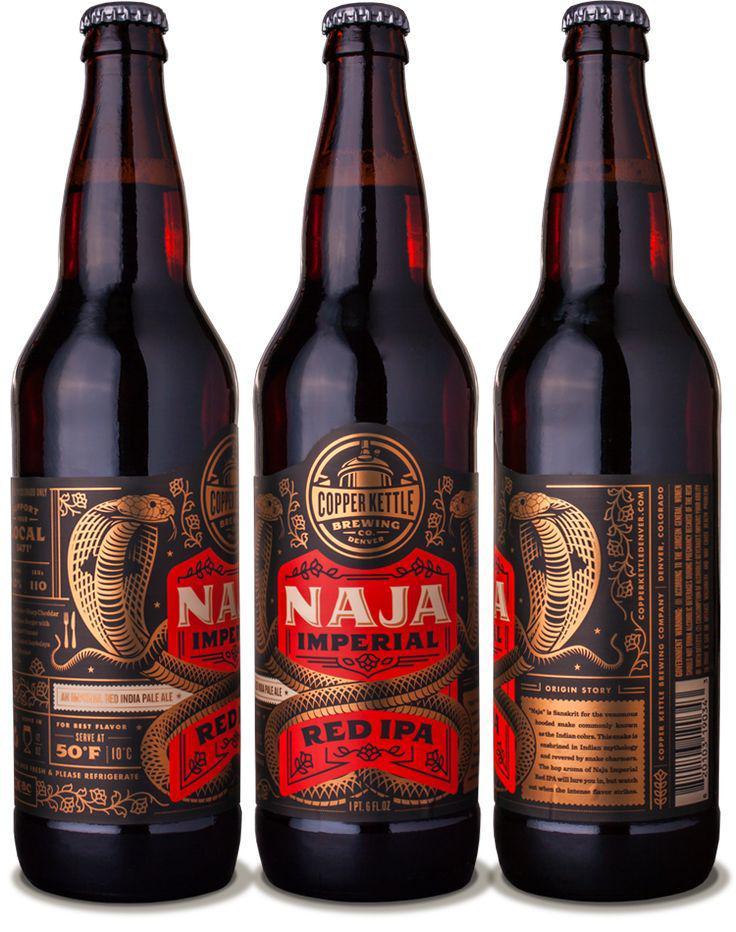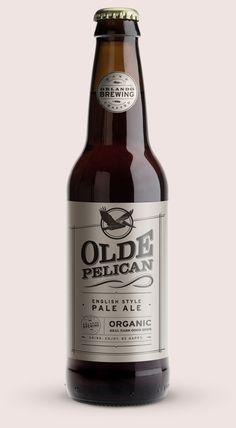The first image is the image on the left, the second image is the image on the right. For the images shown, is this caption "A total of five beer bottles are depicted." true? Answer yes or no. No. 